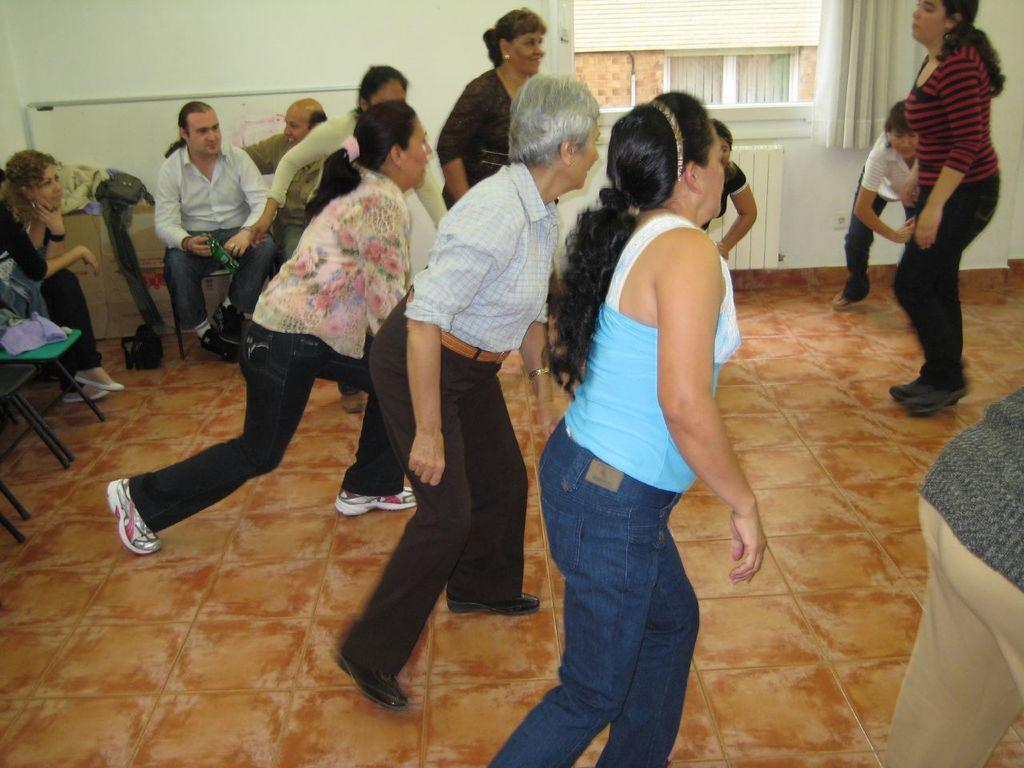What are the people in the image doing? There are people standing and sitting on chairs in the image. What is the surface beneath the people's feet? There is a floor in the image. Are there any window treatments visible in the image? Yes, there are curtains on a window in the image. Can you see any mice running around on the floor in the image? There are no mice visible in the image; only people and chairs are present. Is there an island in the background of the image? There is no island present in the image; it appears to be an indoor setting with a floor, chairs, and people. 